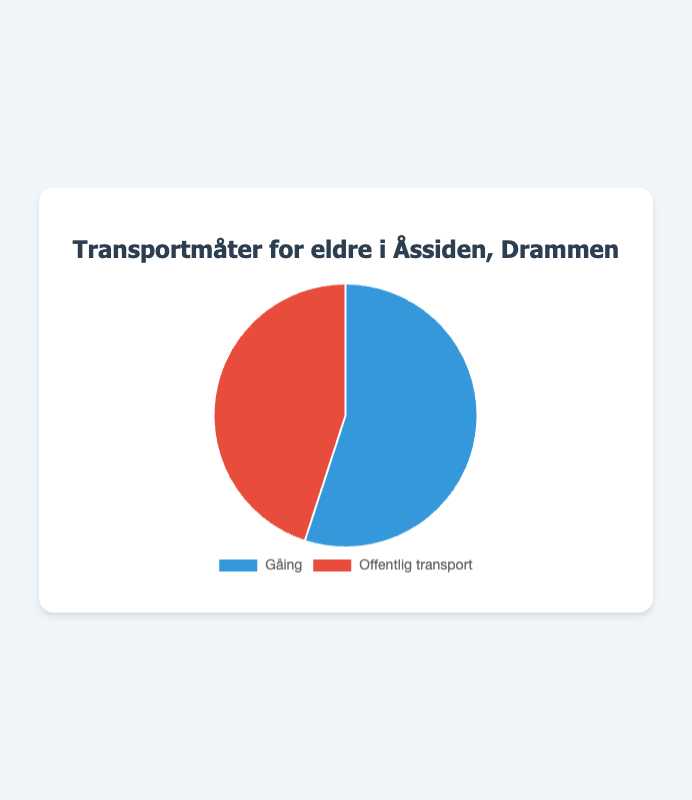What percentage of elderly residents use walking as their mode of transportation? The chart indicates that 55% of elderly residents use walking as their mode of transportation.
Answer: 55% What percentage of elderly residents rely on public transport? The chart shows that 45% of elderly residents rely on public transport.
Answer: 45% Which mode of transportation is more popular among elderly residents? Comparing the percentages, 55% use walking while 45% use public transport, so walking is more popular.
Answer: Walking How much more popular is walking compared to public transport among elderly residents? Walking is 55% and public transport is 45%. The difference is 55% - 45% = 10%.
Answer: 10% What share of the total is public transport if combined with walking? Both modes combined make up 100% as they are the only two categories shown. This is because 55% (walking) + 45% (public transport) = 100%.
Answer: 100% If you were to form a council decision, which mode should get more funding based on popularity? Walking, as it has a larger share of 55% compared to public transport's 45%, should get more funding based on popularity.
Answer: Walking What is the ratio of those who walk to those who use public transport? The ratio of walkers to public transport users is 55 to 45. Simplifying this gives 55/45 = 11/9 or approximately 1.22:1.
Answer: 1.22:1 If you were to create a program for every 100 elderly residents, how many would be walking and how many using public transport? Out of 100 residents, 55% would be walking (55) and 45% would be using public transport (45).
Answer: Walking: 55, Public Transport: 45 How does the color scheme help in distinguishing between the two modes of transportation? The walking segment is shaded in blue, whereas the public transport segment is shaded in red, making it easier to differentiate visually.
Answer: Blue for Walking, Red for Public Transport 